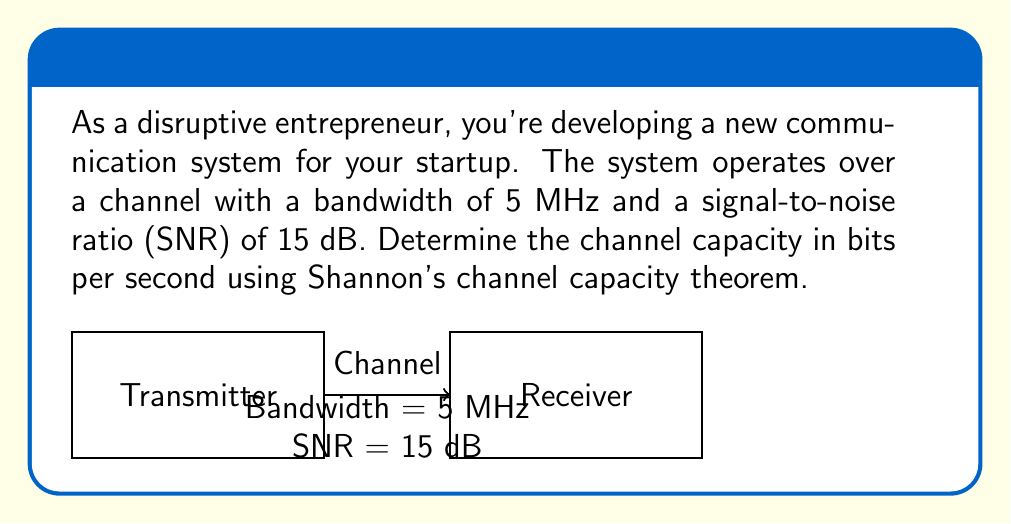Teach me how to tackle this problem. To solve this problem, we'll use Shannon's channel capacity theorem:

$$C = B \log_2(1 + SNR)$$

Where:
$C$ is the channel capacity in bits per second
$B$ is the bandwidth in Hz
$SNR$ is the signal-to-noise ratio (linear, not dB)

Step 1: Convert the given bandwidth to Hz
$B = 5 \text{ MHz} = 5 \times 10^6 \text{ Hz}$

Step 2: Convert SNR from dB to linear scale
$SNR_{linear} = 10^{(SNR_{dB}/10)} = 10^{(15/10)} = 10^{1.5} \approx 31.6228$

Step 3: Apply Shannon's channel capacity theorem
$$\begin{align}
C &= B \log_2(1 + SNR) \\
&= 5 \times 10^6 \log_2(1 + 31.6228) \\
&\approx 5 \times 10^6 \times 5.0444 \\
&\approx 25,222,000 \text{ bits/second}
\end{align}$$

Step 4: Round to a reasonable number of significant figures
$C \approx 25.22 \text{ Mbps}$
Answer: 25.22 Mbps 